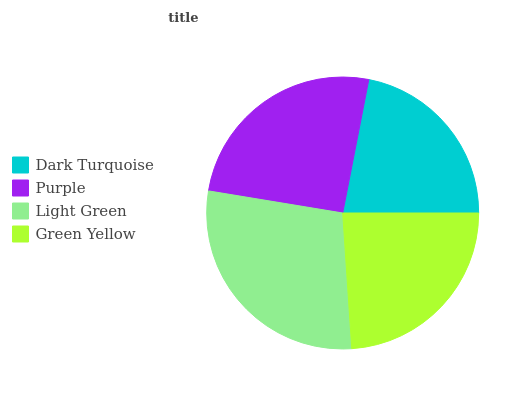Is Dark Turquoise the minimum?
Answer yes or no. Yes. Is Light Green the maximum?
Answer yes or no. Yes. Is Purple the minimum?
Answer yes or no. No. Is Purple the maximum?
Answer yes or no. No. Is Purple greater than Dark Turquoise?
Answer yes or no. Yes. Is Dark Turquoise less than Purple?
Answer yes or no. Yes. Is Dark Turquoise greater than Purple?
Answer yes or no. No. Is Purple less than Dark Turquoise?
Answer yes or no. No. Is Purple the high median?
Answer yes or no. Yes. Is Green Yellow the low median?
Answer yes or no. Yes. Is Green Yellow the high median?
Answer yes or no. No. Is Purple the low median?
Answer yes or no. No. 